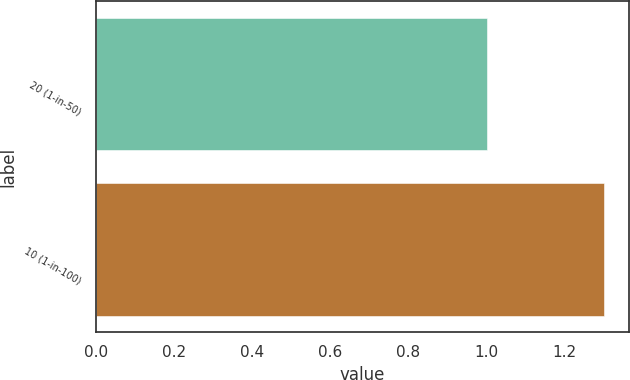<chart> <loc_0><loc_0><loc_500><loc_500><bar_chart><fcel>20 (1-in-50)<fcel>10 (1-in-100)<nl><fcel>1<fcel>1.3<nl></chart> 